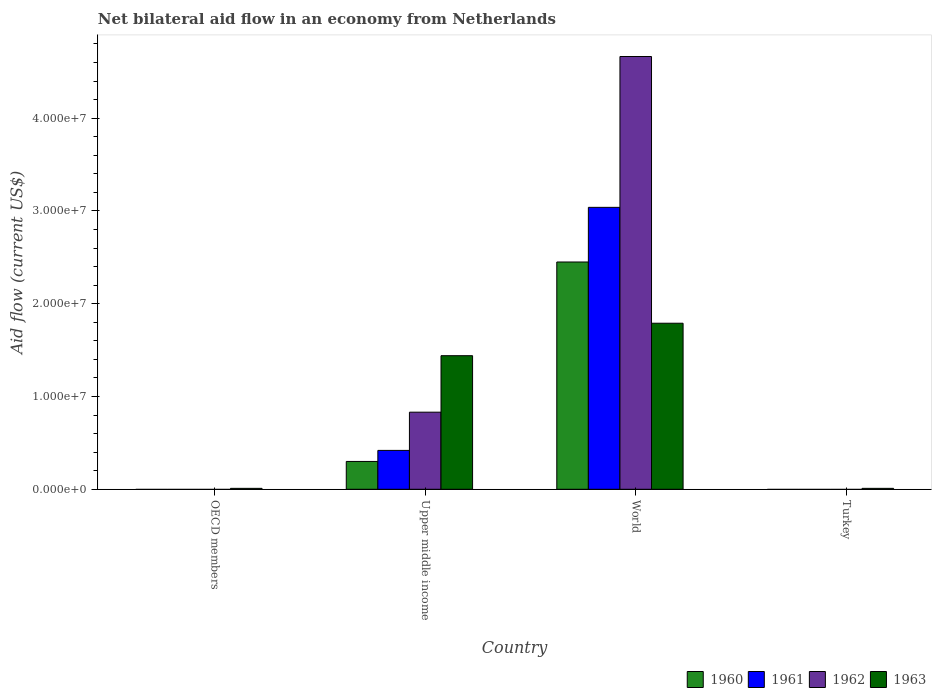How many bars are there on the 3rd tick from the right?
Offer a very short reply. 4. What is the label of the 1st group of bars from the left?
Your answer should be compact. OECD members. In how many cases, is the number of bars for a given country not equal to the number of legend labels?
Provide a short and direct response. 2. What is the net bilateral aid flow in 1963 in World?
Your answer should be very brief. 1.79e+07. Across all countries, what is the maximum net bilateral aid flow in 1962?
Ensure brevity in your answer.  4.66e+07. What is the total net bilateral aid flow in 1961 in the graph?
Give a very brief answer. 3.46e+07. What is the difference between the net bilateral aid flow in 1963 in Turkey and that in World?
Make the answer very short. -1.78e+07. What is the difference between the net bilateral aid flow in 1963 in Upper middle income and the net bilateral aid flow in 1962 in Turkey?
Keep it short and to the point. 1.44e+07. What is the average net bilateral aid flow in 1963 per country?
Make the answer very short. 8.12e+06. What is the difference between the net bilateral aid flow of/in 1962 and net bilateral aid flow of/in 1961 in World?
Your answer should be compact. 1.63e+07. What is the ratio of the net bilateral aid flow in 1963 in Upper middle income to that in World?
Ensure brevity in your answer.  0.8. Is the difference between the net bilateral aid flow in 1962 in Upper middle income and World greater than the difference between the net bilateral aid flow in 1961 in Upper middle income and World?
Provide a short and direct response. No. What is the difference between the highest and the second highest net bilateral aid flow in 1963?
Provide a short and direct response. 3.50e+06. What is the difference between the highest and the lowest net bilateral aid flow in 1960?
Give a very brief answer. 2.45e+07. Is it the case that in every country, the sum of the net bilateral aid flow in 1961 and net bilateral aid flow in 1960 is greater than the sum of net bilateral aid flow in 1962 and net bilateral aid flow in 1963?
Give a very brief answer. No. Is it the case that in every country, the sum of the net bilateral aid flow in 1961 and net bilateral aid flow in 1960 is greater than the net bilateral aid flow in 1963?
Provide a short and direct response. No. Are all the bars in the graph horizontal?
Your answer should be compact. No. How many countries are there in the graph?
Offer a terse response. 4. How are the legend labels stacked?
Make the answer very short. Horizontal. What is the title of the graph?
Offer a terse response. Net bilateral aid flow in an economy from Netherlands. Does "2011" appear as one of the legend labels in the graph?
Give a very brief answer. No. What is the label or title of the Y-axis?
Make the answer very short. Aid flow (current US$). What is the Aid flow (current US$) in 1962 in OECD members?
Keep it short and to the point. 0. What is the Aid flow (current US$) of 1963 in OECD members?
Your response must be concise. 1.00e+05. What is the Aid flow (current US$) in 1961 in Upper middle income?
Your response must be concise. 4.19e+06. What is the Aid flow (current US$) in 1962 in Upper middle income?
Keep it short and to the point. 8.31e+06. What is the Aid flow (current US$) in 1963 in Upper middle income?
Keep it short and to the point. 1.44e+07. What is the Aid flow (current US$) of 1960 in World?
Give a very brief answer. 2.45e+07. What is the Aid flow (current US$) of 1961 in World?
Offer a terse response. 3.04e+07. What is the Aid flow (current US$) in 1962 in World?
Offer a very short reply. 4.66e+07. What is the Aid flow (current US$) of 1963 in World?
Your response must be concise. 1.79e+07. What is the Aid flow (current US$) of 1961 in Turkey?
Provide a succinct answer. 0. Across all countries, what is the maximum Aid flow (current US$) in 1960?
Give a very brief answer. 2.45e+07. Across all countries, what is the maximum Aid flow (current US$) of 1961?
Offer a very short reply. 3.04e+07. Across all countries, what is the maximum Aid flow (current US$) in 1962?
Provide a short and direct response. 4.66e+07. Across all countries, what is the maximum Aid flow (current US$) of 1963?
Keep it short and to the point. 1.79e+07. What is the total Aid flow (current US$) of 1960 in the graph?
Give a very brief answer. 2.75e+07. What is the total Aid flow (current US$) in 1961 in the graph?
Offer a terse response. 3.46e+07. What is the total Aid flow (current US$) of 1962 in the graph?
Ensure brevity in your answer.  5.50e+07. What is the total Aid flow (current US$) of 1963 in the graph?
Ensure brevity in your answer.  3.25e+07. What is the difference between the Aid flow (current US$) of 1963 in OECD members and that in Upper middle income?
Provide a succinct answer. -1.43e+07. What is the difference between the Aid flow (current US$) of 1963 in OECD members and that in World?
Your answer should be very brief. -1.78e+07. What is the difference between the Aid flow (current US$) of 1963 in OECD members and that in Turkey?
Your answer should be very brief. 0. What is the difference between the Aid flow (current US$) in 1960 in Upper middle income and that in World?
Make the answer very short. -2.15e+07. What is the difference between the Aid flow (current US$) in 1961 in Upper middle income and that in World?
Ensure brevity in your answer.  -2.62e+07. What is the difference between the Aid flow (current US$) in 1962 in Upper middle income and that in World?
Make the answer very short. -3.83e+07. What is the difference between the Aid flow (current US$) in 1963 in Upper middle income and that in World?
Keep it short and to the point. -3.50e+06. What is the difference between the Aid flow (current US$) in 1963 in Upper middle income and that in Turkey?
Give a very brief answer. 1.43e+07. What is the difference between the Aid flow (current US$) in 1963 in World and that in Turkey?
Your answer should be compact. 1.78e+07. What is the difference between the Aid flow (current US$) of 1960 in Upper middle income and the Aid flow (current US$) of 1961 in World?
Offer a very short reply. -2.74e+07. What is the difference between the Aid flow (current US$) in 1960 in Upper middle income and the Aid flow (current US$) in 1962 in World?
Offer a terse response. -4.36e+07. What is the difference between the Aid flow (current US$) of 1960 in Upper middle income and the Aid flow (current US$) of 1963 in World?
Make the answer very short. -1.49e+07. What is the difference between the Aid flow (current US$) of 1961 in Upper middle income and the Aid flow (current US$) of 1962 in World?
Offer a terse response. -4.25e+07. What is the difference between the Aid flow (current US$) in 1961 in Upper middle income and the Aid flow (current US$) in 1963 in World?
Provide a short and direct response. -1.37e+07. What is the difference between the Aid flow (current US$) in 1962 in Upper middle income and the Aid flow (current US$) in 1963 in World?
Your response must be concise. -9.59e+06. What is the difference between the Aid flow (current US$) of 1960 in Upper middle income and the Aid flow (current US$) of 1963 in Turkey?
Make the answer very short. 2.90e+06. What is the difference between the Aid flow (current US$) in 1961 in Upper middle income and the Aid flow (current US$) in 1963 in Turkey?
Ensure brevity in your answer.  4.09e+06. What is the difference between the Aid flow (current US$) of 1962 in Upper middle income and the Aid flow (current US$) of 1963 in Turkey?
Keep it short and to the point. 8.21e+06. What is the difference between the Aid flow (current US$) of 1960 in World and the Aid flow (current US$) of 1963 in Turkey?
Provide a succinct answer. 2.44e+07. What is the difference between the Aid flow (current US$) of 1961 in World and the Aid flow (current US$) of 1963 in Turkey?
Ensure brevity in your answer.  3.03e+07. What is the difference between the Aid flow (current US$) of 1962 in World and the Aid flow (current US$) of 1963 in Turkey?
Give a very brief answer. 4.66e+07. What is the average Aid flow (current US$) of 1960 per country?
Give a very brief answer. 6.88e+06. What is the average Aid flow (current US$) of 1961 per country?
Give a very brief answer. 8.64e+06. What is the average Aid flow (current US$) in 1962 per country?
Offer a very short reply. 1.37e+07. What is the average Aid flow (current US$) in 1963 per country?
Offer a very short reply. 8.12e+06. What is the difference between the Aid flow (current US$) in 1960 and Aid flow (current US$) in 1961 in Upper middle income?
Keep it short and to the point. -1.19e+06. What is the difference between the Aid flow (current US$) in 1960 and Aid flow (current US$) in 1962 in Upper middle income?
Offer a terse response. -5.31e+06. What is the difference between the Aid flow (current US$) in 1960 and Aid flow (current US$) in 1963 in Upper middle income?
Provide a succinct answer. -1.14e+07. What is the difference between the Aid flow (current US$) of 1961 and Aid flow (current US$) of 1962 in Upper middle income?
Offer a very short reply. -4.12e+06. What is the difference between the Aid flow (current US$) of 1961 and Aid flow (current US$) of 1963 in Upper middle income?
Provide a succinct answer. -1.02e+07. What is the difference between the Aid flow (current US$) in 1962 and Aid flow (current US$) in 1963 in Upper middle income?
Provide a short and direct response. -6.09e+06. What is the difference between the Aid flow (current US$) of 1960 and Aid flow (current US$) of 1961 in World?
Give a very brief answer. -5.89e+06. What is the difference between the Aid flow (current US$) in 1960 and Aid flow (current US$) in 1962 in World?
Make the answer very short. -2.22e+07. What is the difference between the Aid flow (current US$) of 1960 and Aid flow (current US$) of 1963 in World?
Your response must be concise. 6.60e+06. What is the difference between the Aid flow (current US$) in 1961 and Aid flow (current US$) in 1962 in World?
Offer a very short reply. -1.63e+07. What is the difference between the Aid flow (current US$) in 1961 and Aid flow (current US$) in 1963 in World?
Give a very brief answer. 1.25e+07. What is the difference between the Aid flow (current US$) in 1962 and Aid flow (current US$) in 1963 in World?
Your answer should be compact. 2.88e+07. What is the ratio of the Aid flow (current US$) of 1963 in OECD members to that in Upper middle income?
Provide a short and direct response. 0.01. What is the ratio of the Aid flow (current US$) in 1963 in OECD members to that in World?
Offer a very short reply. 0.01. What is the ratio of the Aid flow (current US$) of 1963 in OECD members to that in Turkey?
Your answer should be compact. 1. What is the ratio of the Aid flow (current US$) in 1960 in Upper middle income to that in World?
Keep it short and to the point. 0.12. What is the ratio of the Aid flow (current US$) of 1961 in Upper middle income to that in World?
Provide a succinct answer. 0.14. What is the ratio of the Aid flow (current US$) in 1962 in Upper middle income to that in World?
Give a very brief answer. 0.18. What is the ratio of the Aid flow (current US$) in 1963 in Upper middle income to that in World?
Your answer should be very brief. 0.8. What is the ratio of the Aid flow (current US$) in 1963 in Upper middle income to that in Turkey?
Offer a terse response. 144. What is the ratio of the Aid flow (current US$) in 1963 in World to that in Turkey?
Your answer should be compact. 179. What is the difference between the highest and the second highest Aid flow (current US$) of 1963?
Provide a succinct answer. 3.50e+06. What is the difference between the highest and the lowest Aid flow (current US$) in 1960?
Your answer should be very brief. 2.45e+07. What is the difference between the highest and the lowest Aid flow (current US$) in 1961?
Provide a short and direct response. 3.04e+07. What is the difference between the highest and the lowest Aid flow (current US$) of 1962?
Give a very brief answer. 4.66e+07. What is the difference between the highest and the lowest Aid flow (current US$) in 1963?
Offer a very short reply. 1.78e+07. 